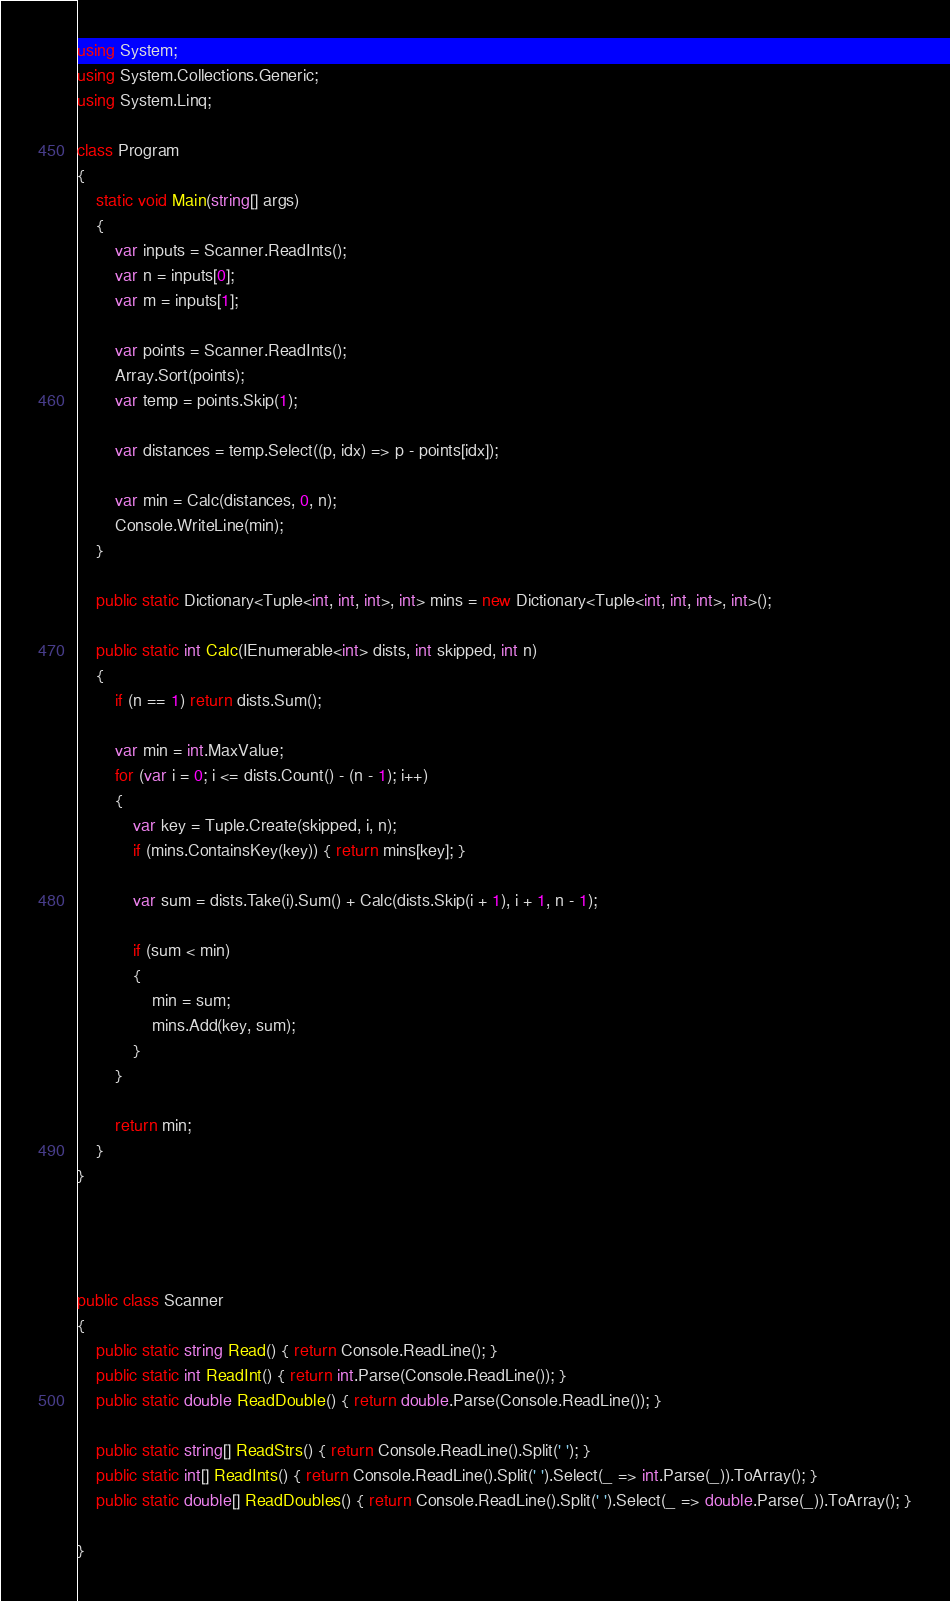Convert code to text. <code><loc_0><loc_0><loc_500><loc_500><_C#_>using System;
using System.Collections.Generic;
using System.Linq;

class Program
{
    static void Main(string[] args)
    {
        var inputs = Scanner.ReadInts();
        var n = inputs[0];
        var m = inputs[1];

        var points = Scanner.ReadInts();
        Array.Sort(points);
        var temp = points.Skip(1);

        var distances = temp.Select((p, idx) => p - points[idx]);

        var min = Calc(distances, 0, n);
        Console.WriteLine(min);
    }

    public static Dictionary<Tuple<int, int, int>, int> mins = new Dictionary<Tuple<int, int, int>, int>();

    public static int Calc(IEnumerable<int> dists, int skipped, int n)
    {
        if (n == 1) return dists.Sum();

        var min = int.MaxValue;
        for (var i = 0; i <= dists.Count() - (n - 1); i++)
        {
            var key = Tuple.Create(skipped, i, n);
            if (mins.ContainsKey(key)) { return mins[key]; }

            var sum = dists.Take(i).Sum() + Calc(dists.Skip(i + 1), i + 1, n - 1);

            if (sum < min)
            {
                min = sum;
                mins.Add(key, sum);
            }
        }

        return min;
    }
}




public class Scanner
{
    public static string Read() { return Console.ReadLine(); }
    public static int ReadInt() { return int.Parse(Console.ReadLine()); }
    public static double ReadDouble() { return double.Parse(Console.ReadLine()); }

    public static string[] ReadStrs() { return Console.ReadLine().Split(' '); }
    public static int[] ReadInts() { return Console.ReadLine().Split(' ').Select(_ => int.Parse(_)).ToArray(); }
    public static double[] ReadDoubles() { return Console.ReadLine().Split(' ').Select(_ => double.Parse(_)).ToArray(); }

}
</code> 